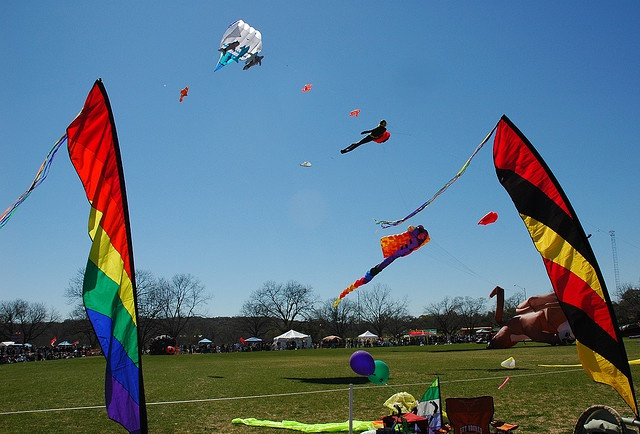Describe the objects in this image and their specific colors. I can see kite in gray, black, red, brown, and darkblue tones, kite in gray, black, brown, and maroon tones, kite in gray, brown, black, navy, and red tones, kite in gray, lightgray, and darkgray tones, and kite in gray, darkgray, black, and darkgreen tones in this image. 